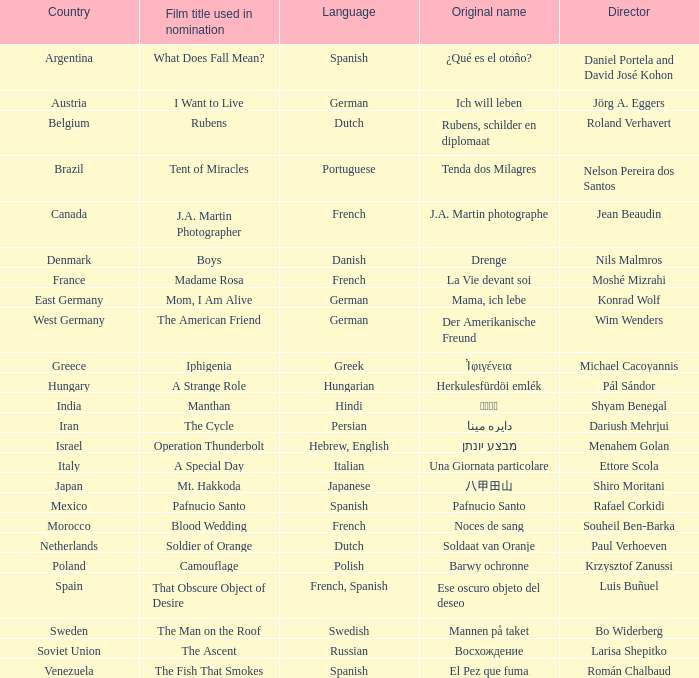What is the title of the German film that is originally called Mama, Ich Lebe? Mom, I Am Alive. 